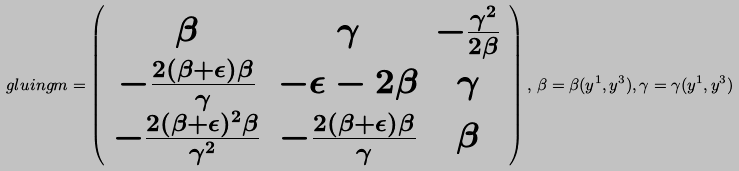Convert formula to latex. <formula><loc_0><loc_0><loc_500><loc_500>\ g l u i n g m = \left ( \begin{array} { c c c } \beta & \gamma & - \frac { \gamma ^ { 2 } } { 2 \beta } \\ - \frac { 2 ( \beta + \epsilon ) \beta } { \gamma } & - \epsilon - 2 \beta & \gamma \\ - \frac { 2 ( \beta + \epsilon ) ^ { 2 } \beta } { \gamma ^ { 2 } } & - \frac { 2 ( \beta + \epsilon ) \beta } { \gamma } & \beta \end{array} \right ) , \, \beta = \beta ( y ^ { 1 } , y ^ { 3 } ) , \gamma = \gamma ( y ^ { 1 } , y ^ { 3 } )</formula> 